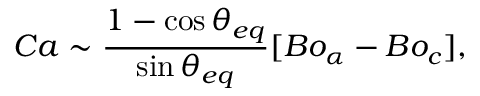Convert formula to latex. <formula><loc_0><loc_0><loc_500><loc_500>C a \sim \frac { 1 - \cos { \theta _ { e q } } } { \sin { \theta _ { e q } } } [ B o _ { \alpha } - B o _ { c } ] ,</formula> 